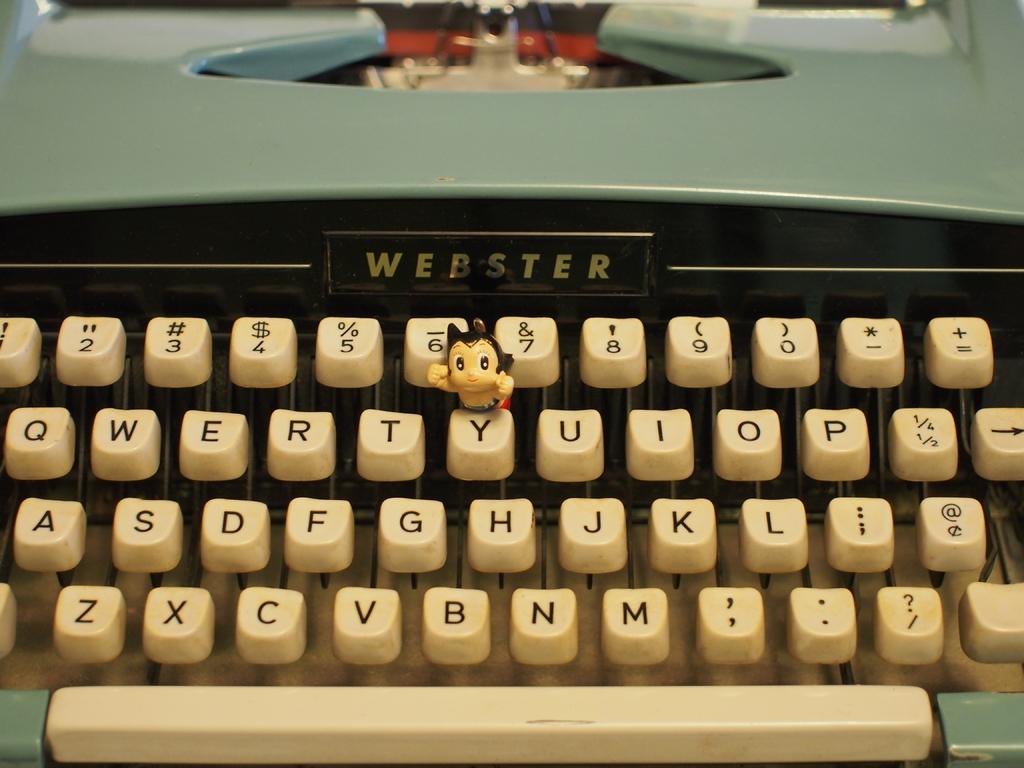Is this a webster typewriter?
Offer a very short reply. Yes. Is this a qwerty keyboard?
Make the answer very short. Yes. 